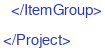Convert code to text. <code><loc_0><loc_0><loc_500><loc_500><_XML_>  </ItemGroup>

</Project>
</code> 